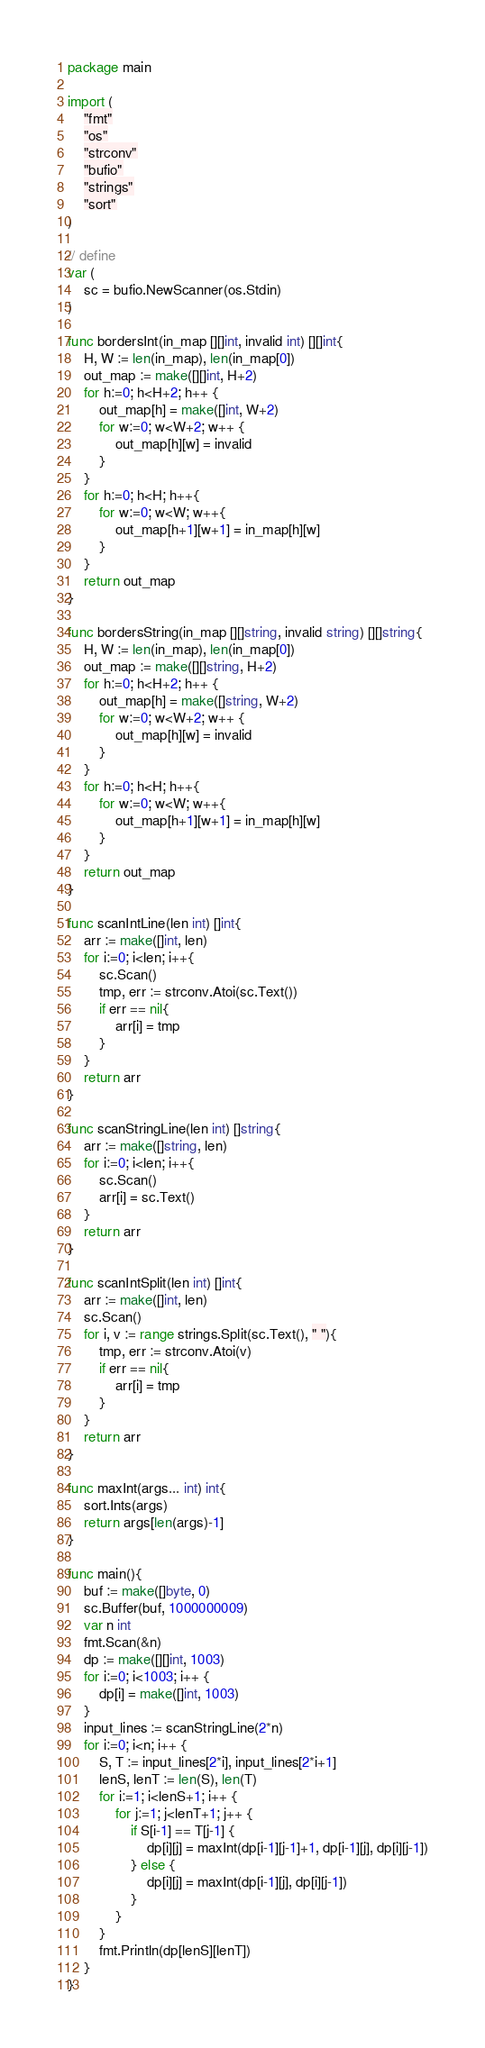Convert code to text. <code><loc_0><loc_0><loc_500><loc_500><_Go_>package main

import (
	"fmt"
	"os"
	"strconv"
	"bufio"
	"strings"
	"sort"
)

// define
var (
	sc = bufio.NewScanner(os.Stdin)
)

func bordersInt(in_map [][]int, invalid int) [][]int{
	H, W := len(in_map), len(in_map[0])
	out_map := make([][]int, H+2)
	for h:=0; h<H+2; h++ {
		out_map[h] = make([]int, W+2)
		for w:=0; w<W+2; w++ {
			out_map[h][w] = invalid
		}
	}
	for h:=0; h<H; h++{
		for w:=0; w<W; w++{
			out_map[h+1][w+1] = in_map[h][w] 
		}
	}
	return out_map
}

func bordersString(in_map [][]string, invalid string) [][]string{
	H, W := len(in_map), len(in_map[0])
	out_map := make([][]string, H+2)
	for h:=0; h<H+2; h++ {
		out_map[h] = make([]string, W+2)
		for w:=0; w<W+2; w++ {
			out_map[h][w] = invalid
		}
	}
	for h:=0; h<H; h++{
		for w:=0; w<W; w++{
			out_map[h+1][w+1] = in_map[h][w] 
		}
	}
	return out_map
}

func scanIntLine(len int) []int{
	arr := make([]int, len)
	for i:=0; i<len; i++{
		sc.Scan()
		tmp, err := strconv.Atoi(sc.Text())
		if err == nil{
			arr[i] = tmp
		}
	}
	return arr
}

func scanStringLine(len int) []string{
	arr := make([]string, len)
	for i:=0; i<len; i++{
		sc.Scan()
		arr[i] = sc.Text()
	}
	return arr
}

func scanIntSplit(len int) []int{
	arr := make([]int, len)
	sc.Scan()
	for i, v := range strings.Split(sc.Text(), " "){
		tmp, err := strconv.Atoi(v)
		if err == nil{
			arr[i] = tmp
		}
	}
	return arr
}

func maxInt(args... int) int{
	sort.Ints(args)
	return args[len(args)-1]
}

func main(){
	buf := make([]byte, 0)
    sc.Buffer(buf, 1000000009)
	var n int 
	fmt.Scan(&n)
	dp := make([][]int, 1003)
	for i:=0; i<1003; i++ {
		dp[i] = make([]int, 1003)
	}
	input_lines := scanStringLine(2*n)
	for i:=0; i<n; i++ {
		S, T := input_lines[2*i], input_lines[2*i+1]
		lenS, lenT := len(S), len(T)
		for i:=1; i<lenS+1; i++ {
			for j:=1; j<lenT+1; j++ {
				if S[i-1] == T[j-1] {
					dp[i][j] = maxInt(dp[i-1][j-1]+1, dp[i-1][j], dp[i][j-1])
				} else {
					dp[i][j] = maxInt(dp[i-1][j], dp[i][j-1])
				}
			}
		}
		fmt.Println(dp[lenS][lenT])
	}
}
</code> 